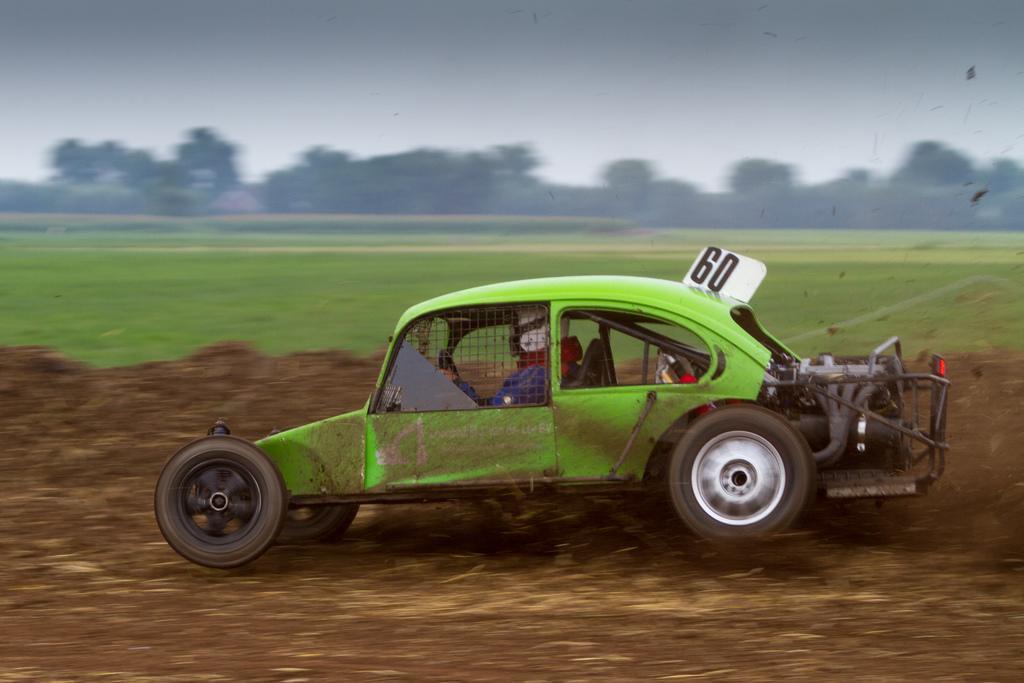In one or two sentences, can you explain what this image depicts? In this image I can see a green color car visible on ground , at the top there is the sky and trees visible in the middle and in the car I can see a person, on top of car I can see name plate on which I can see numbers. 